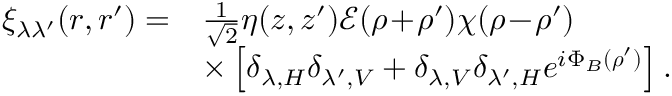Convert formula to latex. <formula><loc_0><loc_0><loc_500><loc_500>\begin{array} { r l } { \xi _ { \lambda \lambda ^ { \prime } } ( r , r ^ { \prime } ) = } & { \frac { 1 } { \sqrt { 2 } } \eta ( z , z ^ { \prime } ) \mathcal { E } ( \rho \, + \, \rho ^ { \prime } ) \chi ( \rho \, - \, \rho ^ { \prime } ) } \\ & { \times \left [ \delta _ { \lambda , H } \delta _ { \lambda ^ { \prime } , V } + \delta _ { \lambda , V } \delta _ { \lambda ^ { \prime } , H } e ^ { i \Phi _ { B } ( \rho ^ { \prime } ) } \right ] . } \end{array}</formula> 